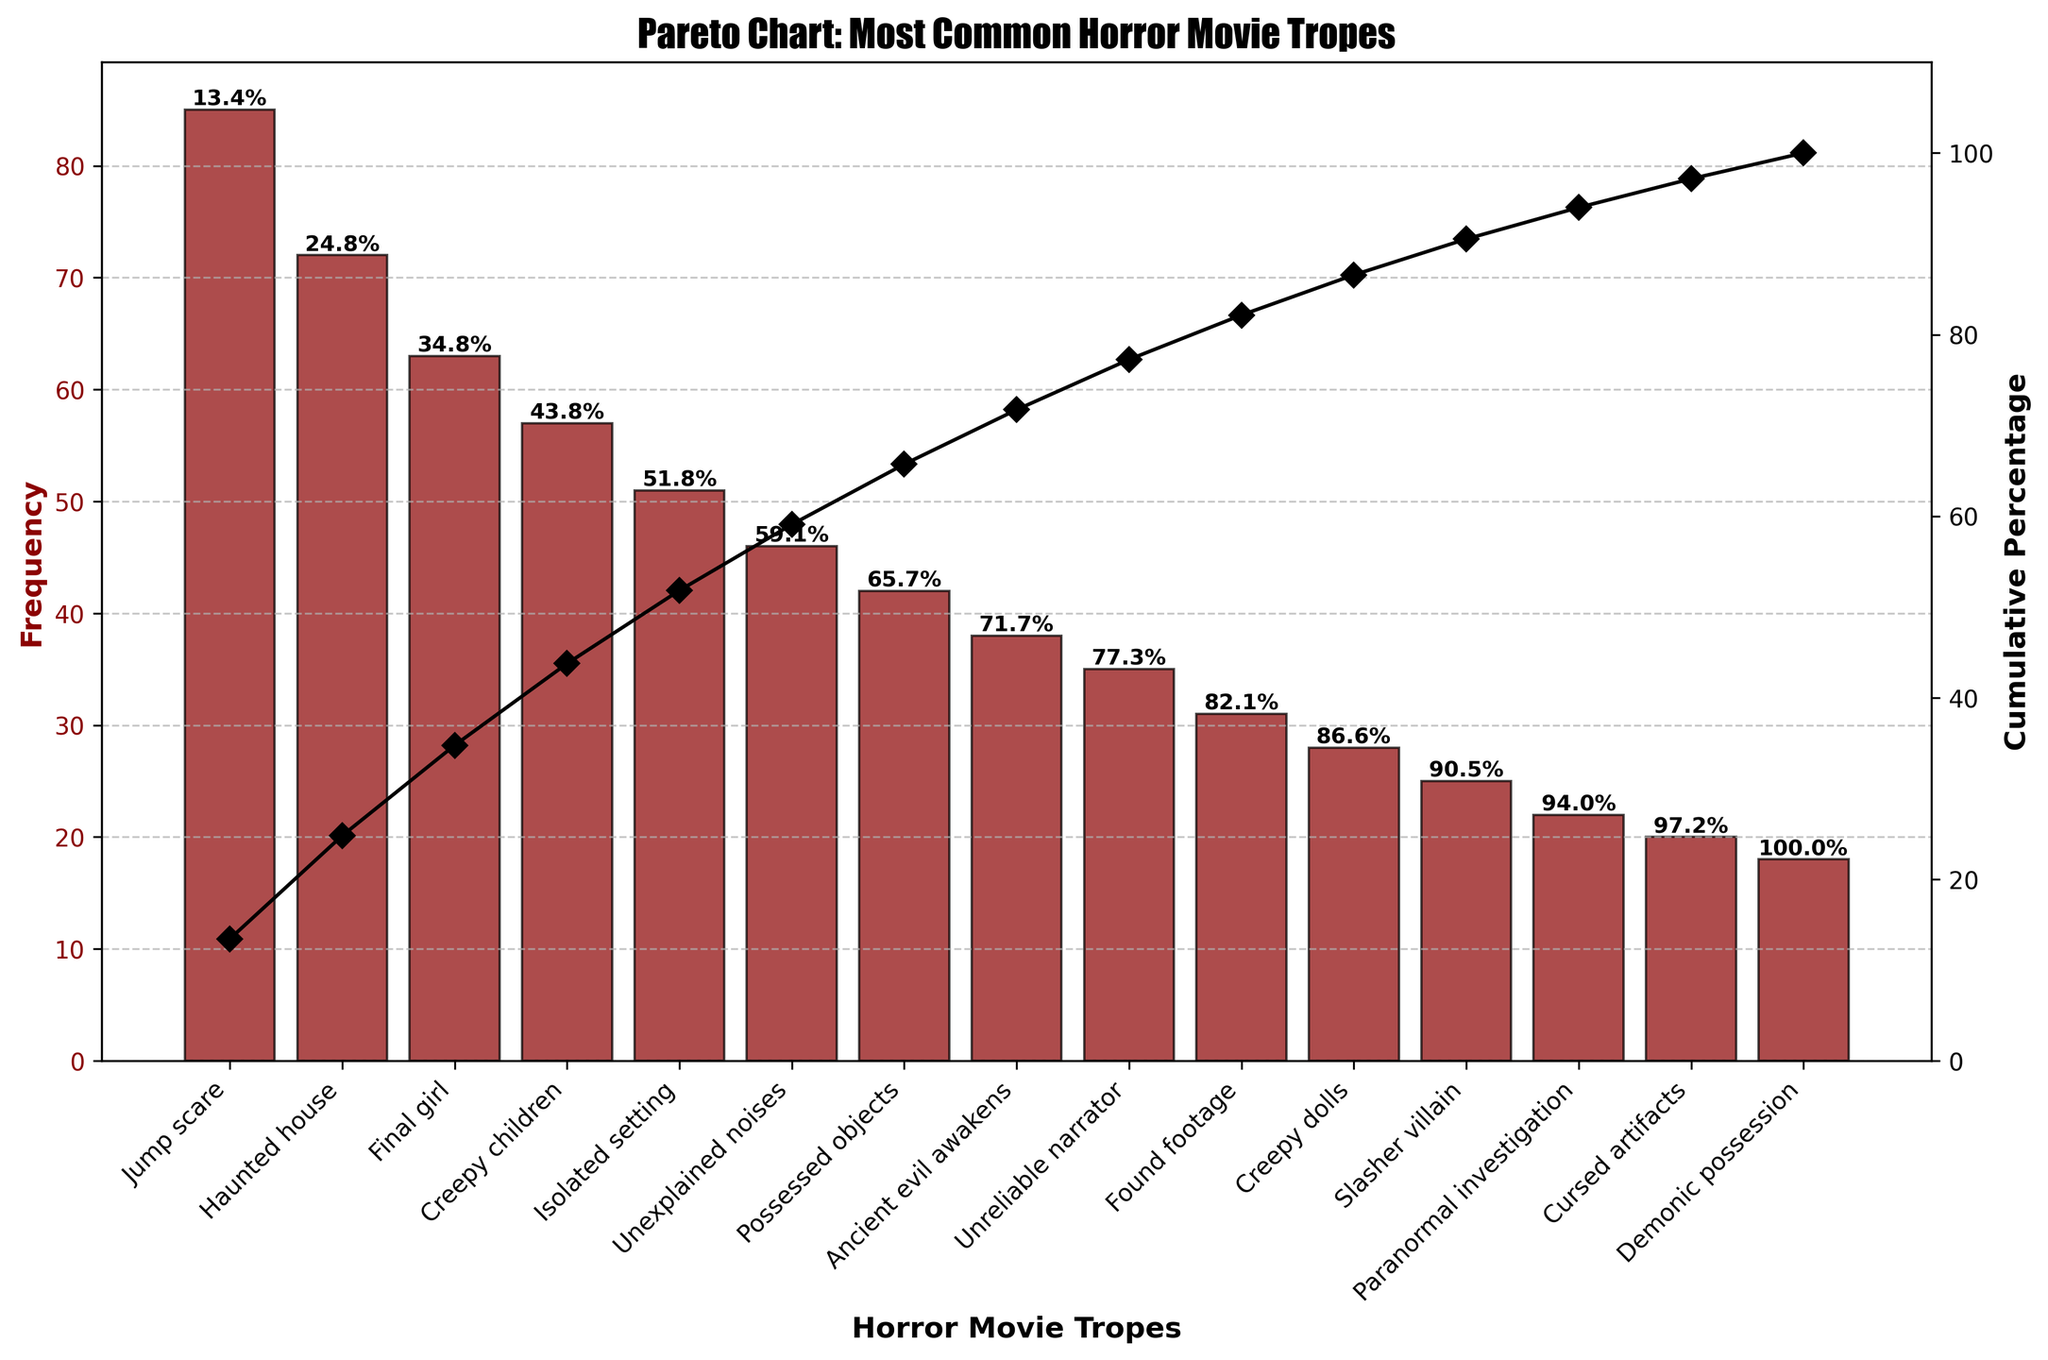Which horror movie trope is used the most frequently? Looking at the highest bar in the chart, the "Jump scare" trope has the highest frequency.
Answer: Jump scare What is the title of the Pareto chart? The title is displayed at the top of the chart.
Answer: Pareto Chart: Most Common Horror Movie Tropes How many tropes have a frequency greater than 50? The bars above the 50 mark are "Jump scare", "Haunted house", "Final girl", "Creepy children", and "Isolated setting".
Answer: 5 What is the cumulative percentage of the top three most frequent tropes? Add the percentages at the top of the first three bars: 24.4% (Jump scare) + 45.1% (Haunted house) + 62.1% (Final girl).
Answer: 62.1% Which trope has a frequency of 38? The bar labeled "Ancient evil awakens" has a frequency of 38.
Answer: Ancient evil awakens What is the cumulative percentage at the "Unreliable narrator" trope? Look at the percentage on top of the "Unreliable narrator" bar.
Answer: 81.8% How many tropes have a cumulative percentage less than 60%? Identify bars with cumulative percentages less than 60%: "Jump scare" (24.4%), "Haunted house" (45.1%), "Final girl" (62.1%, so it’s included just before hitting 60%), "Creepy children" (75.4%).
Answer: 4 Which are used more frequently, "Creepy dolls" or "Slasher villain"? Compare the heights of the bars for "Creepy dolls" and "Slasher villain".
Answer: Creepy dolls What is the final cumulative percentage on the chart? The cumulative line reaches up to 100% at the "Demonic possession" trope.
Answer: 100% Does the "Found footage" trope have a higher or lower frequency than "Possessed objects"? Compare the heights of the bars for "Found footage" (31) and "Possessed objects" (42).
Answer: Lower 